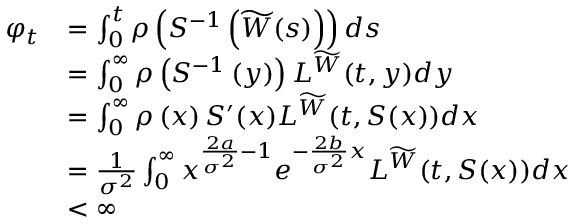<formula> <loc_0><loc_0><loc_500><loc_500>\begin{array} { r l } { \varphi _ { t } } & { = \int _ { 0 } ^ { t } \rho \left ( S ^ { - 1 } \left ( \widetilde { W } ( s ) \right ) \right ) d s } \\ & { = \int _ { 0 } ^ { \infty } \rho \left ( S ^ { - 1 } \left ( y \right ) \right ) L ^ { \widetilde { W } } ( t , y ) d y } \\ & { = \int _ { 0 } ^ { \infty } \rho \left ( x \right ) S ^ { \prime } ( x ) L ^ { \widetilde { W } } ( t , S ( x ) ) d x } \\ & { = \frac { 1 } { \sigma ^ { 2 } } \int _ { 0 } ^ { \infty } x ^ { \frac { 2 a } { \sigma ^ { 2 } } - 1 } e ^ { - \frac { 2 b } { \sigma ^ { 2 } } x } L ^ { \widetilde { W } } ( t , S ( x ) ) d x } \\ & { < \infty } \end{array}</formula> 